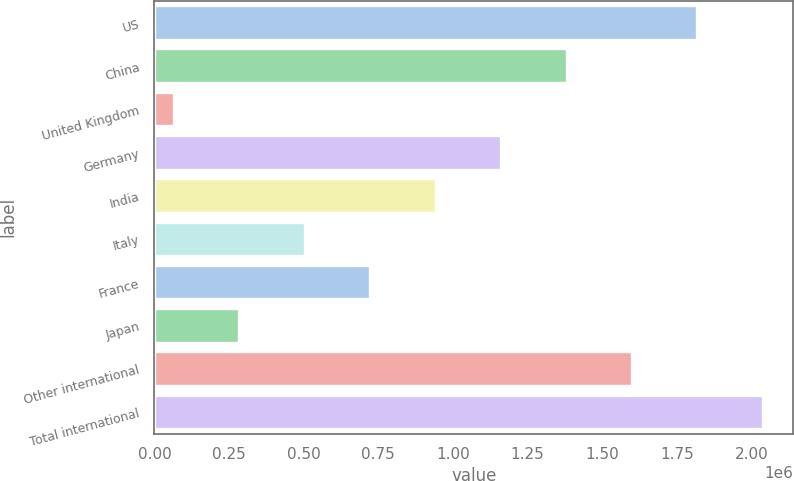Convert chart. <chart><loc_0><loc_0><loc_500><loc_500><bar_chart><fcel>US<fcel>China<fcel>United Kingdom<fcel>Germany<fcel>India<fcel>Italy<fcel>France<fcel>Japan<fcel>Other international<fcel>Total international<nl><fcel>1.81862e+06<fcel>1.38025e+06<fcel>65164<fcel>1.16107e+06<fcel>941891<fcel>503528<fcel>722709<fcel>284346<fcel>1.59944e+06<fcel>2.0378e+06<nl></chart> 